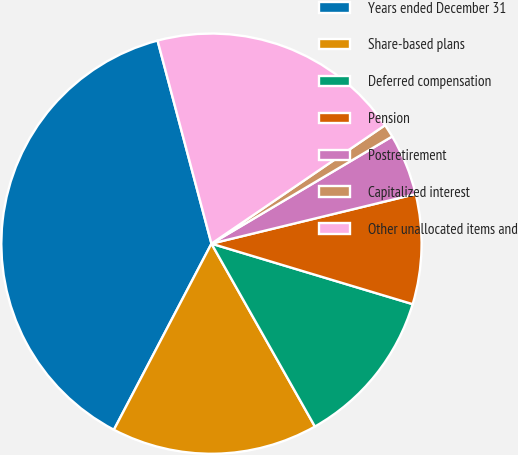Convert chart to OTSL. <chart><loc_0><loc_0><loc_500><loc_500><pie_chart><fcel>Years ended December 31<fcel>Share-based plans<fcel>Deferred compensation<fcel>Pension<fcel>Postretirement<fcel>Capitalized interest<fcel>Other unallocated items and<nl><fcel>38.19%<fcel>15.88%<fcel>12.16%<fcel>8.44%<fcel>4.73%<fcel>1.01%<fcel>19.6%<nl></chart> 